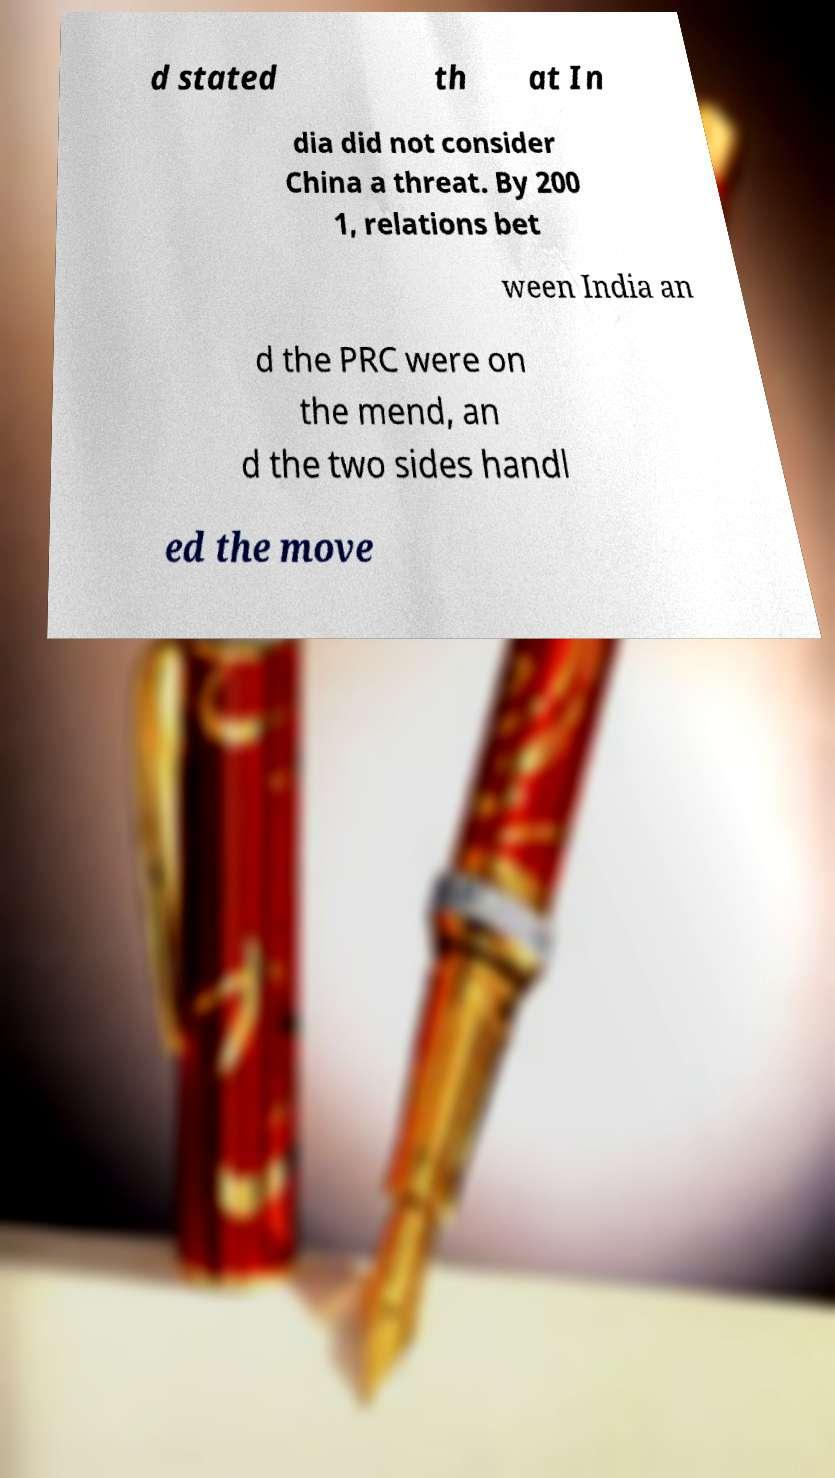Could you assist in decoding the text presented in this image and type it out clearly? d stated th at In dia did not consider China a threat. By 200 1, relations bet ween India an d the PRC were on the mend, an d the two sides handl ed the move 